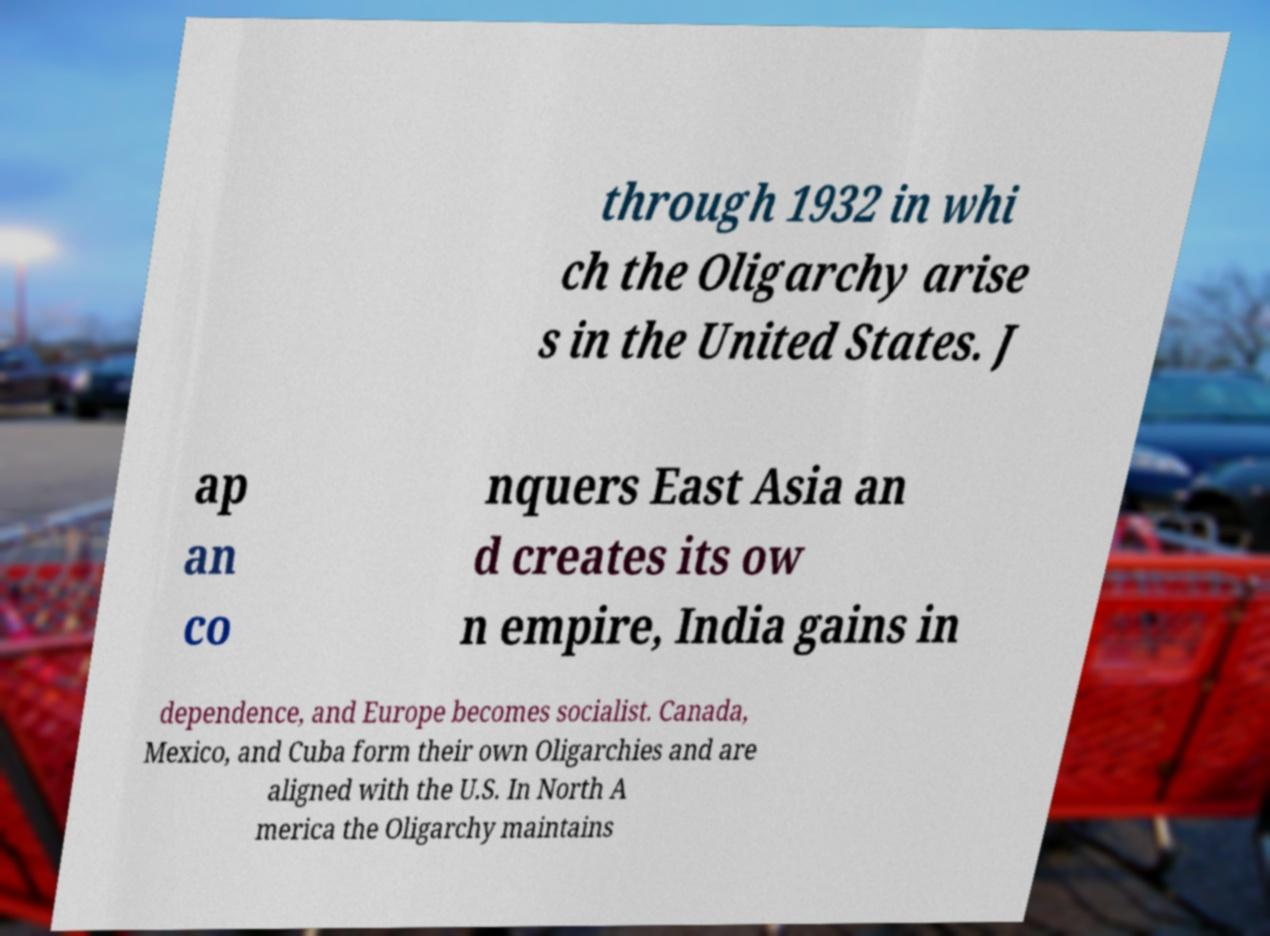Could you assist in decoding the text presented in this image and type it out clearly? through 1932 in whi ch the Oligarchy arise s in the United States. J ap an co nquers East Asia an d creates its ow n empire, India gains in dependence, and Europe becomes socialist. Canada, Mexico, and Cuba form their own Oligarchies and are aligned with the U.S. In North A merica the Oligarchy maintains 